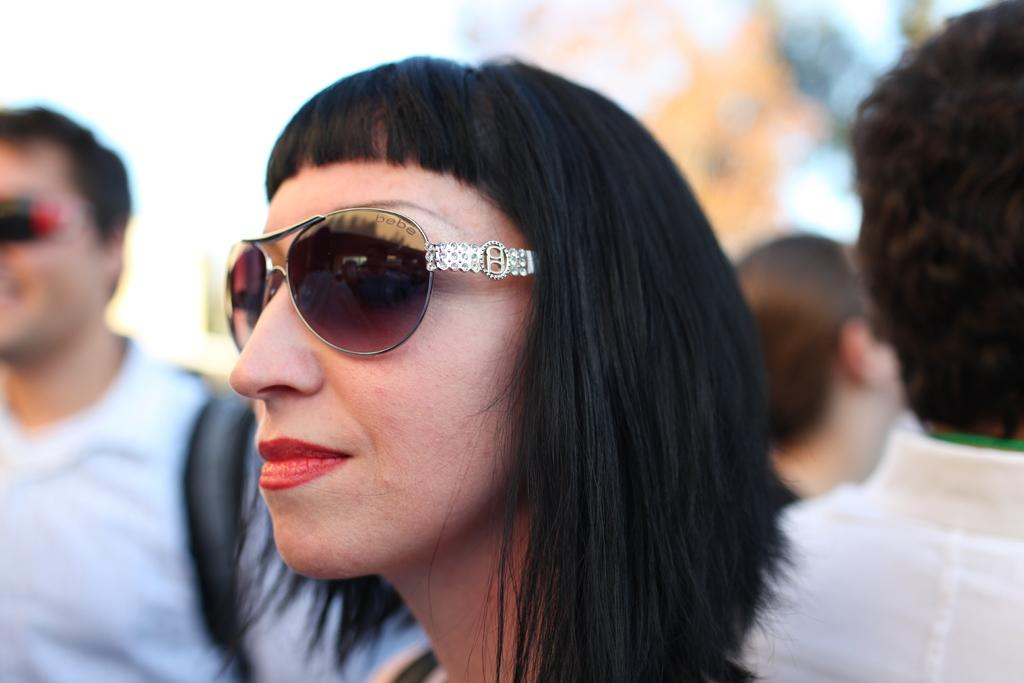Who is the main subject in the image? There is a woman in the image. What is the woman wearing on her face? The woman is wearing shades. Can you describe the men in the image? There are men on the left and right sides of the image, and they are wearing white shirts. What is the condition of the background in the image? The background of the image is blurred. What type of clam is being used by the woman in the image? There is no clam present in the image; the woman is wearing shades. What machine is the woman operating in the image? There is no machine present in the image; the woman is simply standing there with shades on. 